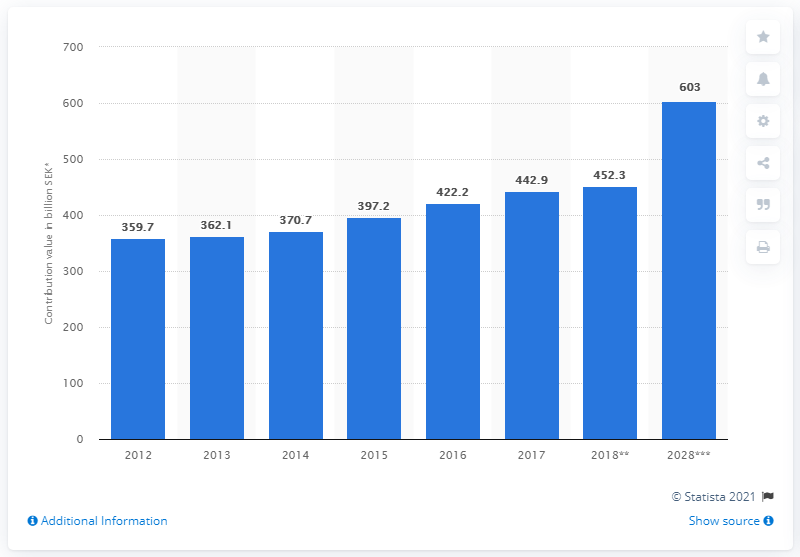Specify some key components in this picture. The travel and tourism industry contributed an estimated 452.3 billion SEK (Swedish Krona) to the Gross Domestic Product (GDP) of Sweden in 2018. 